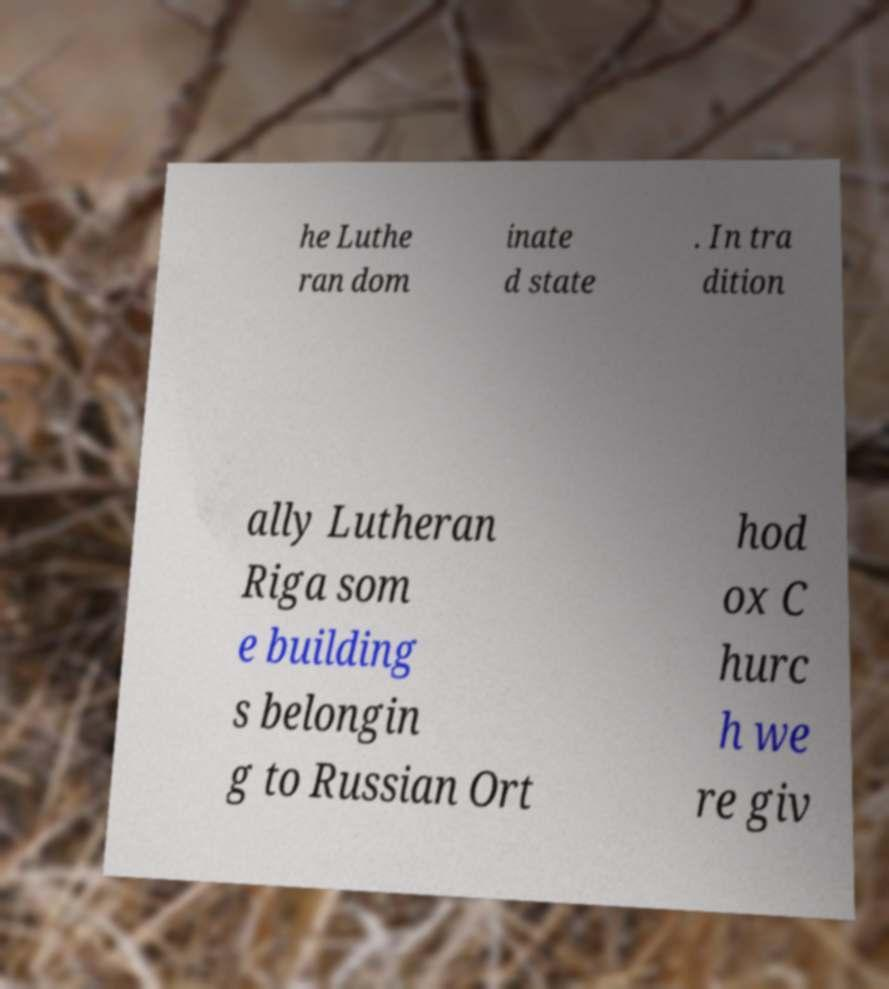For documentation purposes, I need the text within this image transcribed. Could you provide that? he Luthe ran dom inate d state . In tra dition ally Lutheran Riga som e building s belongin g to Russian Ort hod ox C hurc h we re giv 